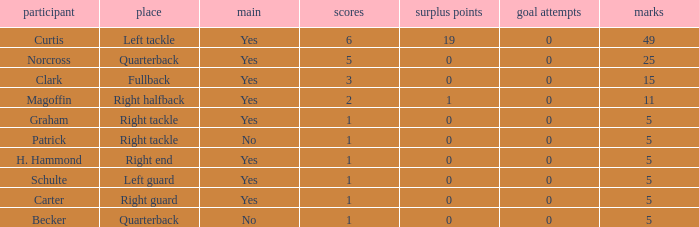Name the most touchdowns for norcross 5.0. 